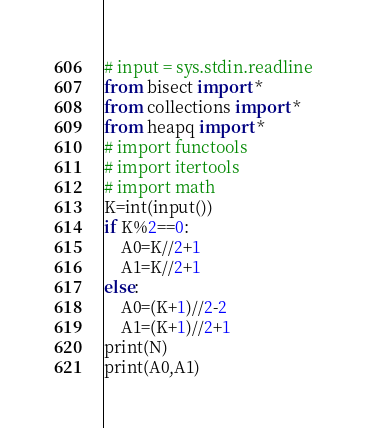<code> <loc_0><loc_0><loc_500><loc_500><_Python_># input = sys.stdin.readline
from bisect import *
from collections import *
from heapq import *
# import functools
# import itertools
# import math
K=int(input())
if K%2==0:
    A0=K//2+1
    A1=K//2+1
else:
    A0=(K+1)//2-2
    A1=(K+1)//2+1
print(N)
print(A0,A1)
</code> 